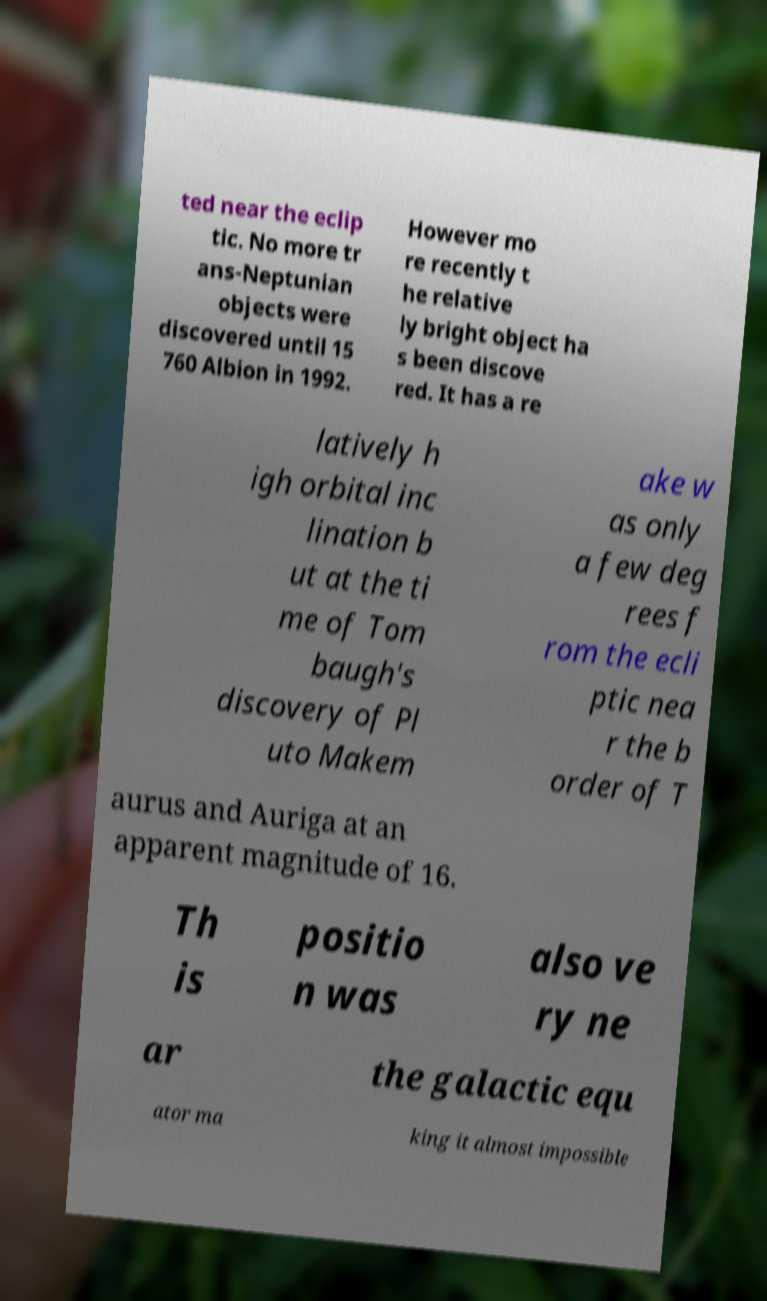Please identify and transcribe the text found in this image. ted near the eclip tic. No more tr ans-Neptunian objects were discovered until 15 760 Albion in 1992. However mo re recently t he relative ly bright object ha s been discove red. It has a re latively h igh orbital inc lination b ut at the ti me of Tom baugh's discovery of Pl uto Makem ake w as only a few deg rees f rom the ecli ptic nea r the b order of T aurus and Auriga at an apparent magnitude of 16. Th is positio n was also ve ry ne ar the galactic equ ator ma king it almost impossible 